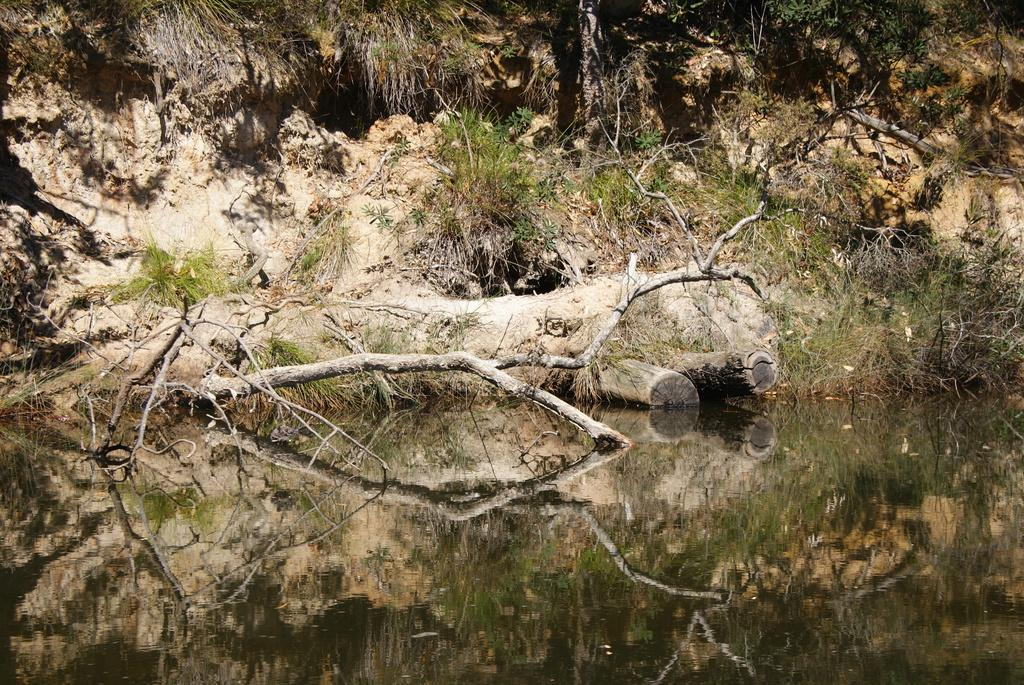What is the primary element visible in the picture? There is water in the picture. What can be seen near the water? There are plants near the water. What else is present in the picture? There is a branch in the picture. How are the plants and the branch depicted in the image? The plants and the branch are reflected in the water. What type of paper can be seen being turned in the room in the image? There is: There is no room or paper present in the image; it features water, plants, and a branch. 